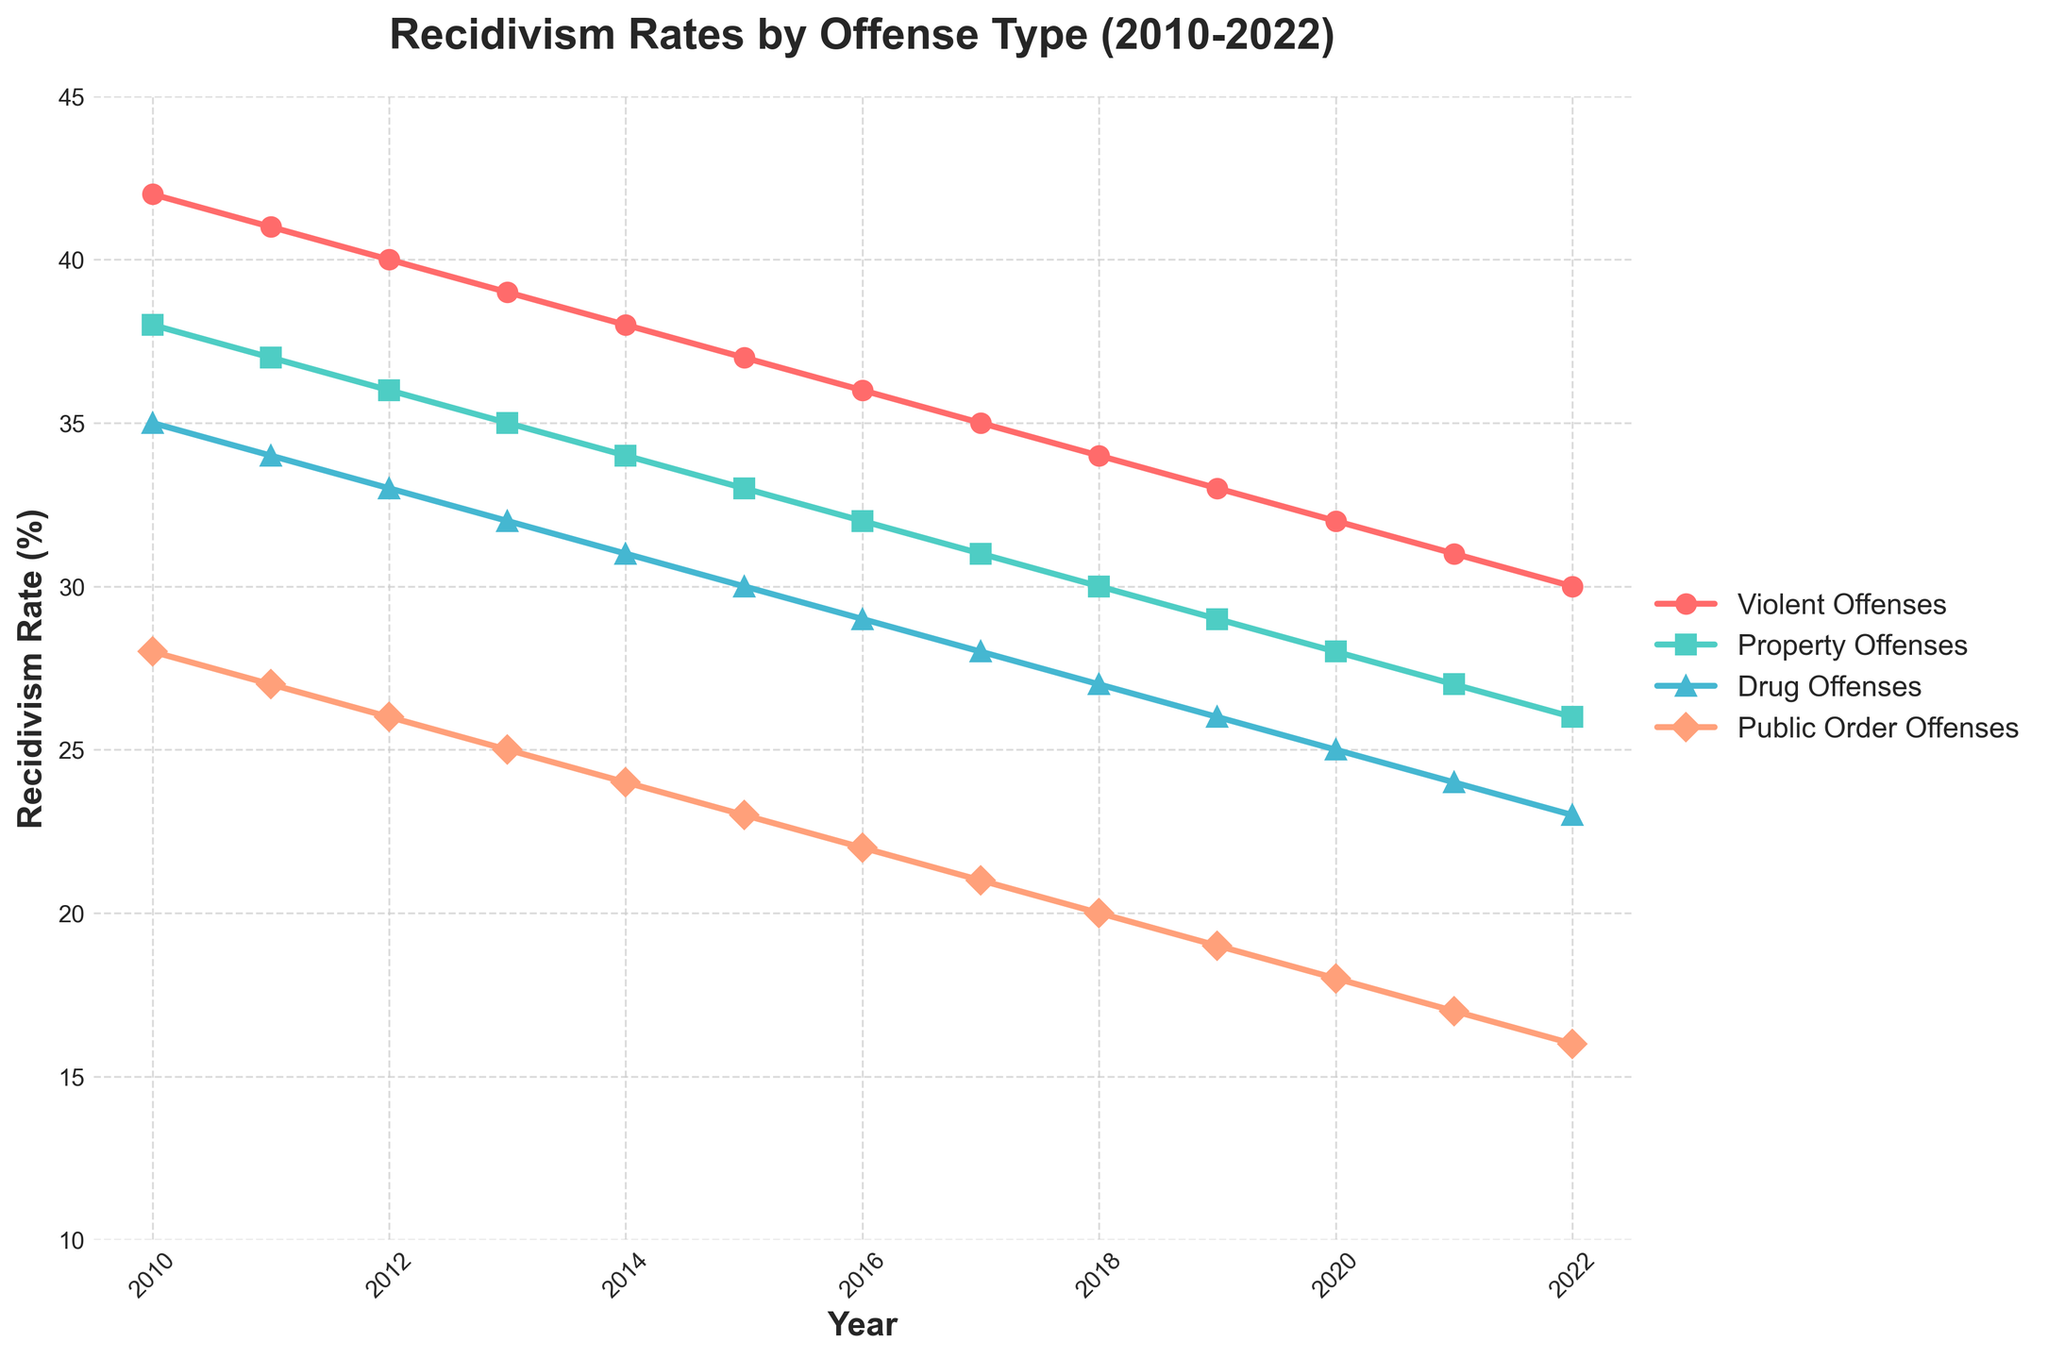What year did the rate of Violent Offenses drop below 35% for the first time? We look at the Violent Offenses line on the plot and identify the inflection points. The rate drops below 35% between 2016 and 2017. By tracing the marker for 2016, we see it's at 36%, and for 2017, it is at 35%, so it confirms it dropped below 35% in 2017.
Answer: 2017 Which offense type had the steepest decline in recidivism rates from 2010 to 2022? We analyze the slopes of all the lines. We can see that Violent Offenses had the steepest decline, going from 42% in 2010 to 30% in 2022, a drop of 12%. The other offenses had lesser declines.
Answer: Violent Offenses In which year were the recidivism rates of Property Offenses and Drug Offenses the same? We trace the lines of Property Offenses and Drug Offenses and find where they intersect. This happens at two points: once in the early years around 2018 and once in the later years. By carefully inspecting, the intersection is around 2020. They both are at 28% in 2017.
Answer: 2017 What is the average recidivism rate for Public Order Offenses from 2010 to 2022? Sum up the recidivism rates of Public Order Offenses from the chart for each year and divide by the number of years (13). ((28+27+26+25+24+23+22+21+20+19+18+17+16)/13 = 21.77)
Answer: 21.77% Which offense type had the lowest recidivism rate in 2022, and what was that rate? Look at the markers for each offense type in the year 2022. The lowest marker is for Public Order Offenses at 16%.
Answer: Public Order Offenses, 16% How much did the recidivism rate for Drug Offenses change from 2010 to 2022? Identify the recidivism rates for Drug Offenses in 2010 and 2022. The rate was 35% in 2010 and 23% in 2022. The change is 35% - 23% = 12%.
Answer: 12% Did any offense type have a recidivism rate greater than 40% after 2013? Check the lines for all offense types from 2014 onward. The highest values do not cross the 40% mark after 2013.
Answer: No During what period did Property Offenses see the most significant drop in recidivism rates? Observe the Property Offenses line and look for the steepest downward slope. This appears to be between 2015 and 2019.
Answer: 2015-2019 